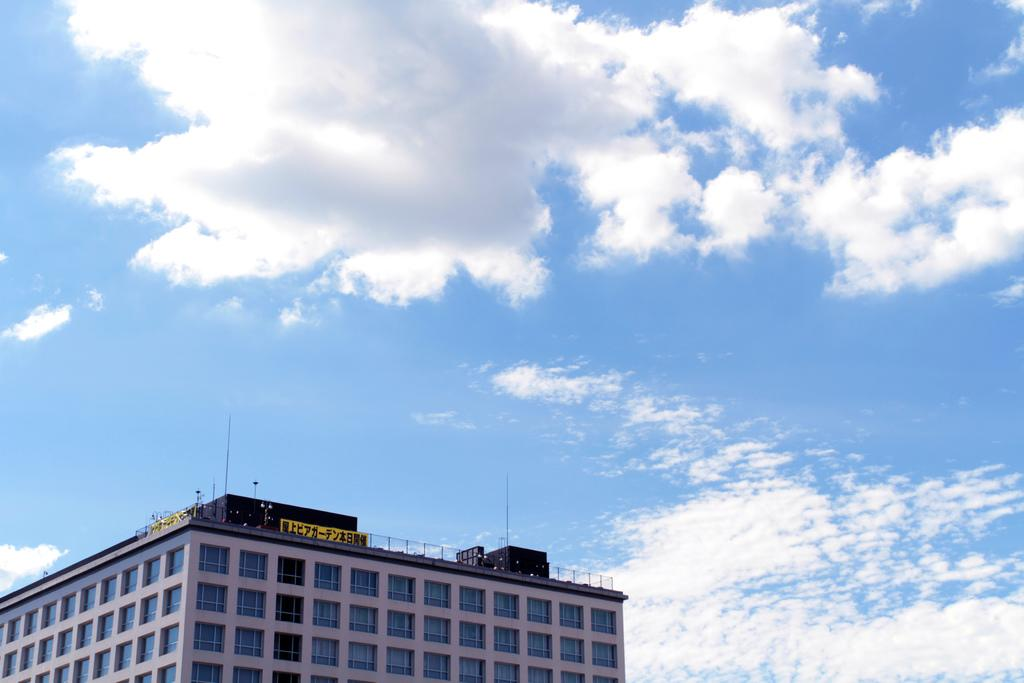What type of structure is present in the image? There is a building in the image. What can be seen in the background of the image? The sky is visible in the background of the image. How many oranges are hanging from the building in the image? There are no oranges present in the image. What type of bean is growing on the side of the building in the image? There are no beans present in the image. 